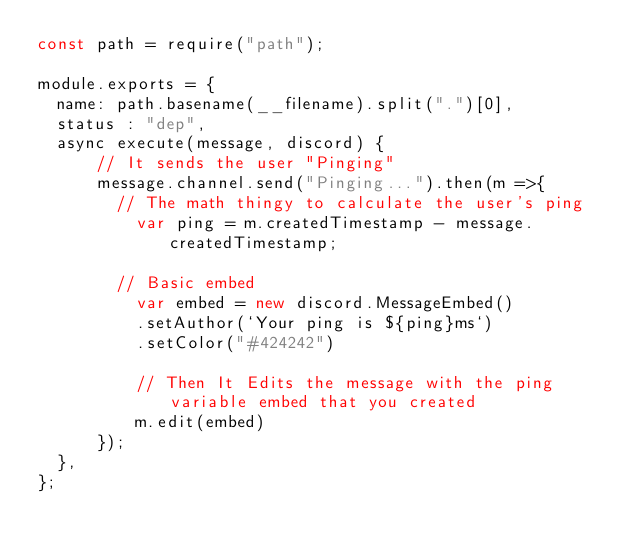<code> <loc_0><loc_0><loc_500><loc_500><_JavaScript_>const path = require("path");

module.exports = {
  name: path.basename(__filename).split(".")[0],
  status : "dep",
  async execute(message, discord) {
      // It sends the user "Pinging"
      message.channel.send("Pinging...").then(m =>{
        // The math thingy to calculate the user's ping
          var ping = m.createdTimestamp - message.createdTimestamp;

        // Basic embed
          var embed = new discord.MessageEmbed()
          .setAuthor(`Your ping is ${ping}ms`)
          .setColor("#424242")
          
          // Then It Edits the message with the ping variable embed that you created
          m.edit(embed)
      });
  },
};</code> 